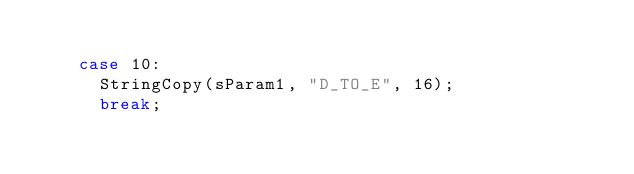Convert code to text. <code><loc_0><loc_0><loc_500><loc_500><_C_>		
		case 10:
			StringCopy(sParam1, "D_TO_E", 16);
			break;</code> 